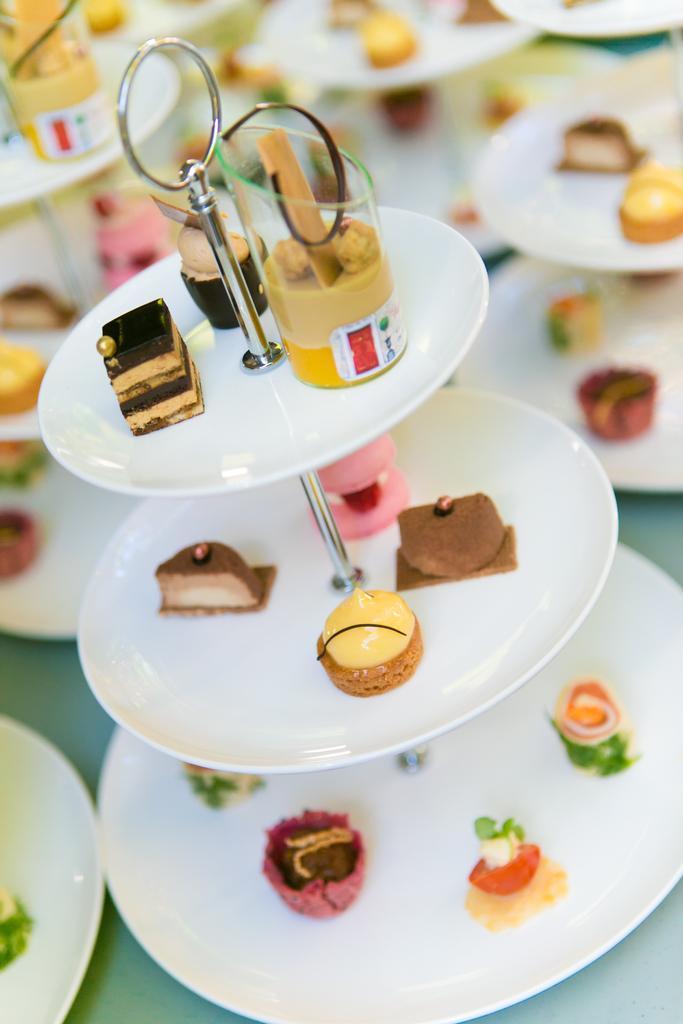Describe this image in one or two sentences. In this image we can see food placed in a plate stand. In the background we can see plate stands and food. 